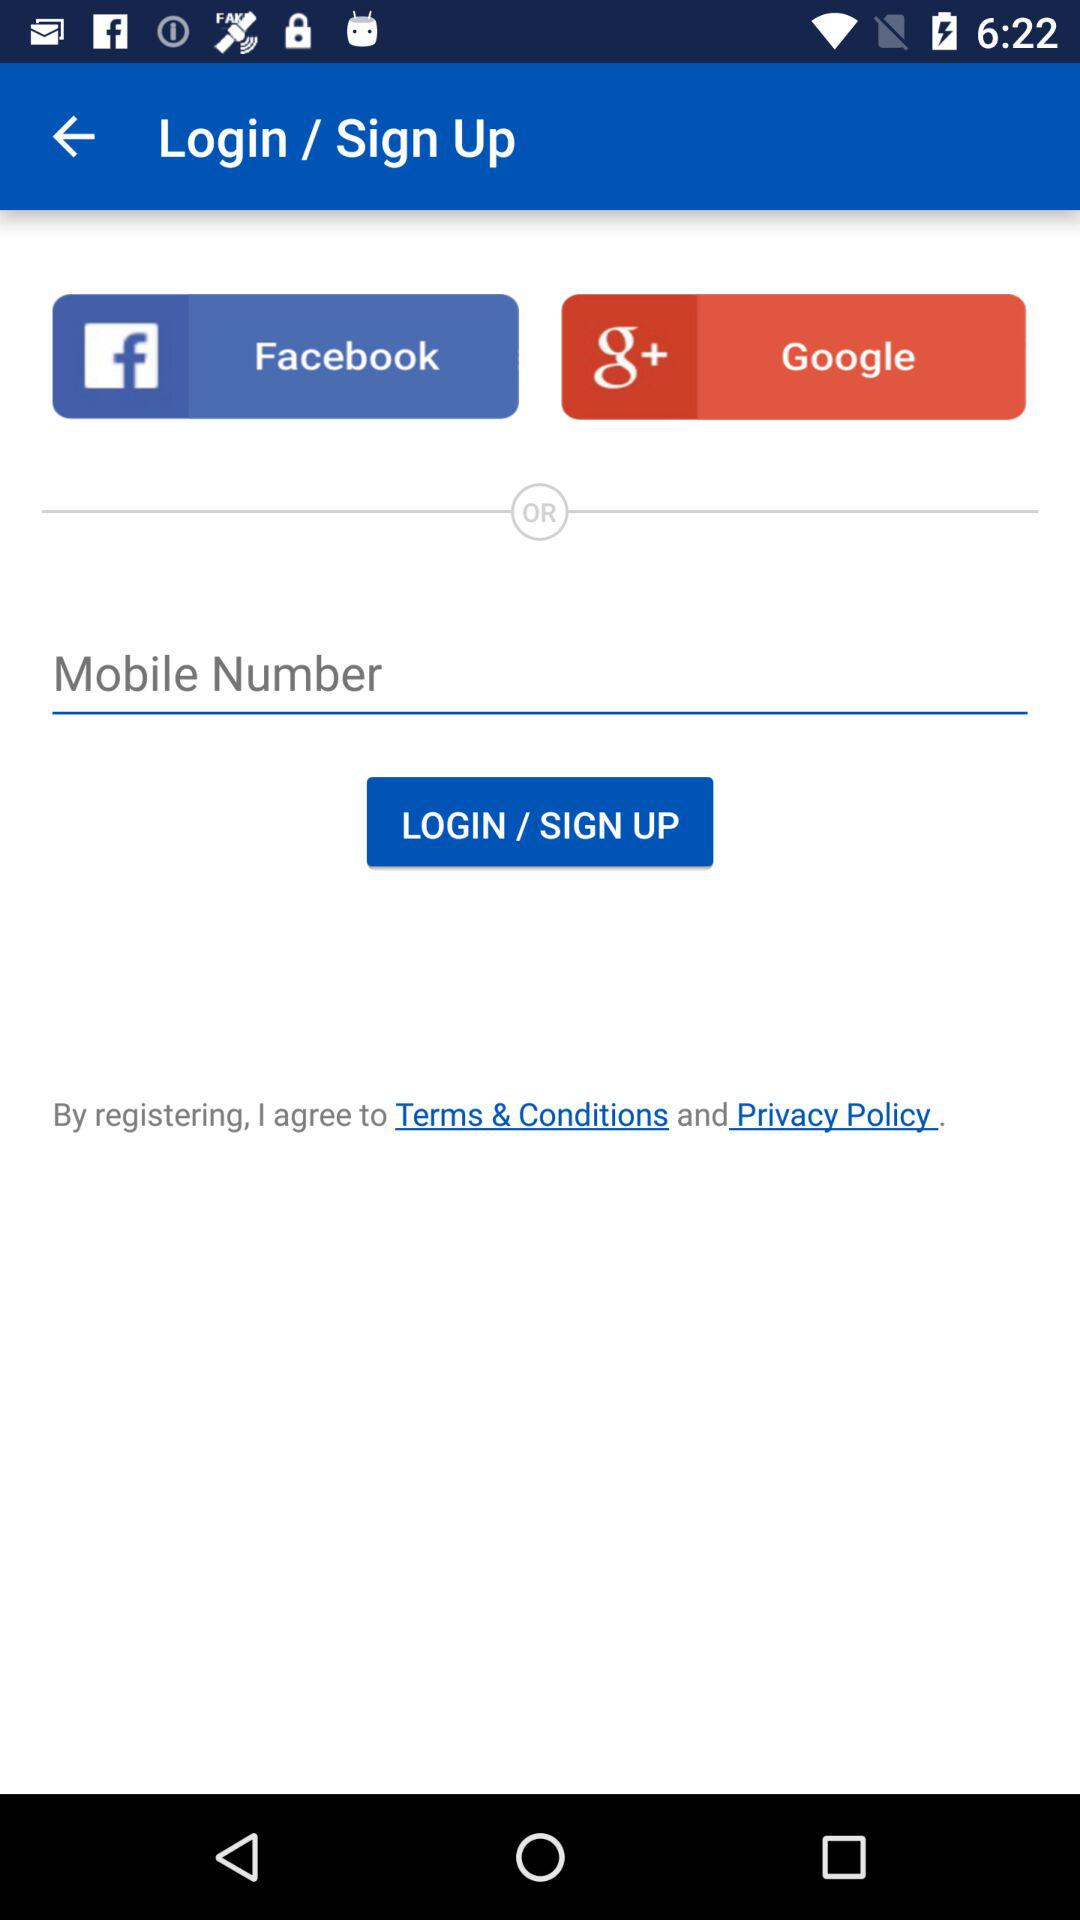Which applications can be used to log in or sign up? The applications that can be used to log in or sign up are "Facebook" and "Google". 